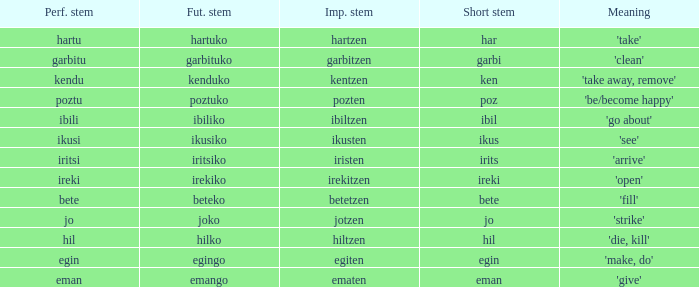What is the short stem for garbitzen? Garbi. 